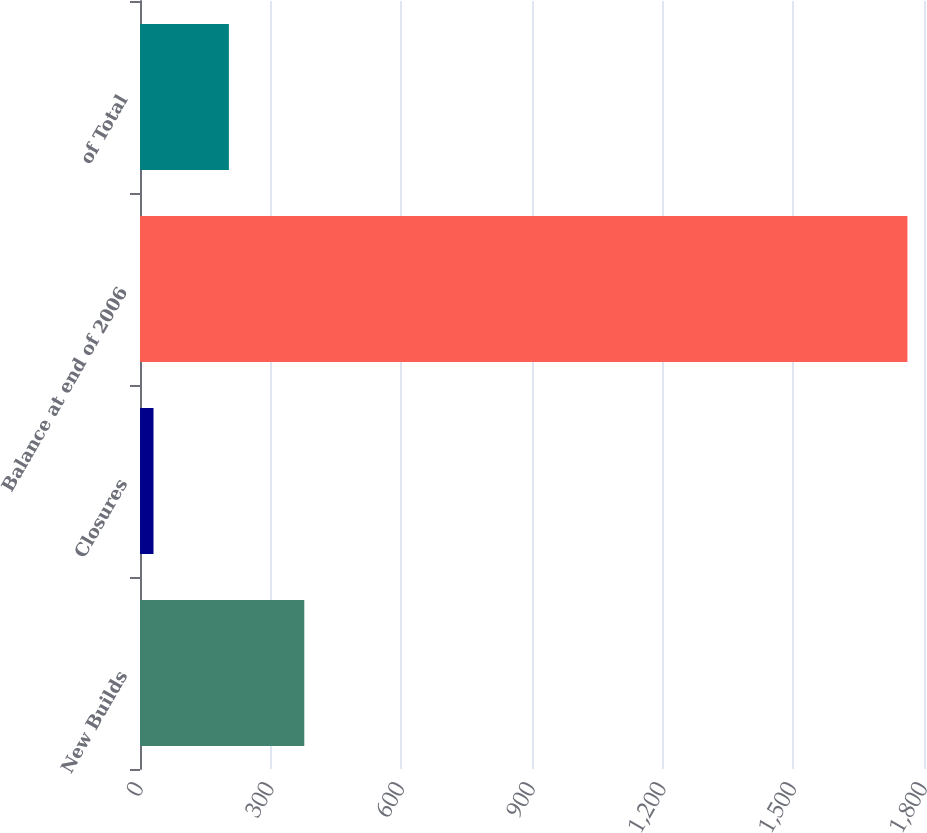Convert chart to OTSL. <chart><loc_0><loc_0><loc_500><loc_500><bar_chart><fcel>New Builds<fcel>Closures<fcel>Balance at end of 2006<fcel>of Total<nl><fcel>377.2<fcel>31<fcel>1762<fcel>204.1<nl></chart> 